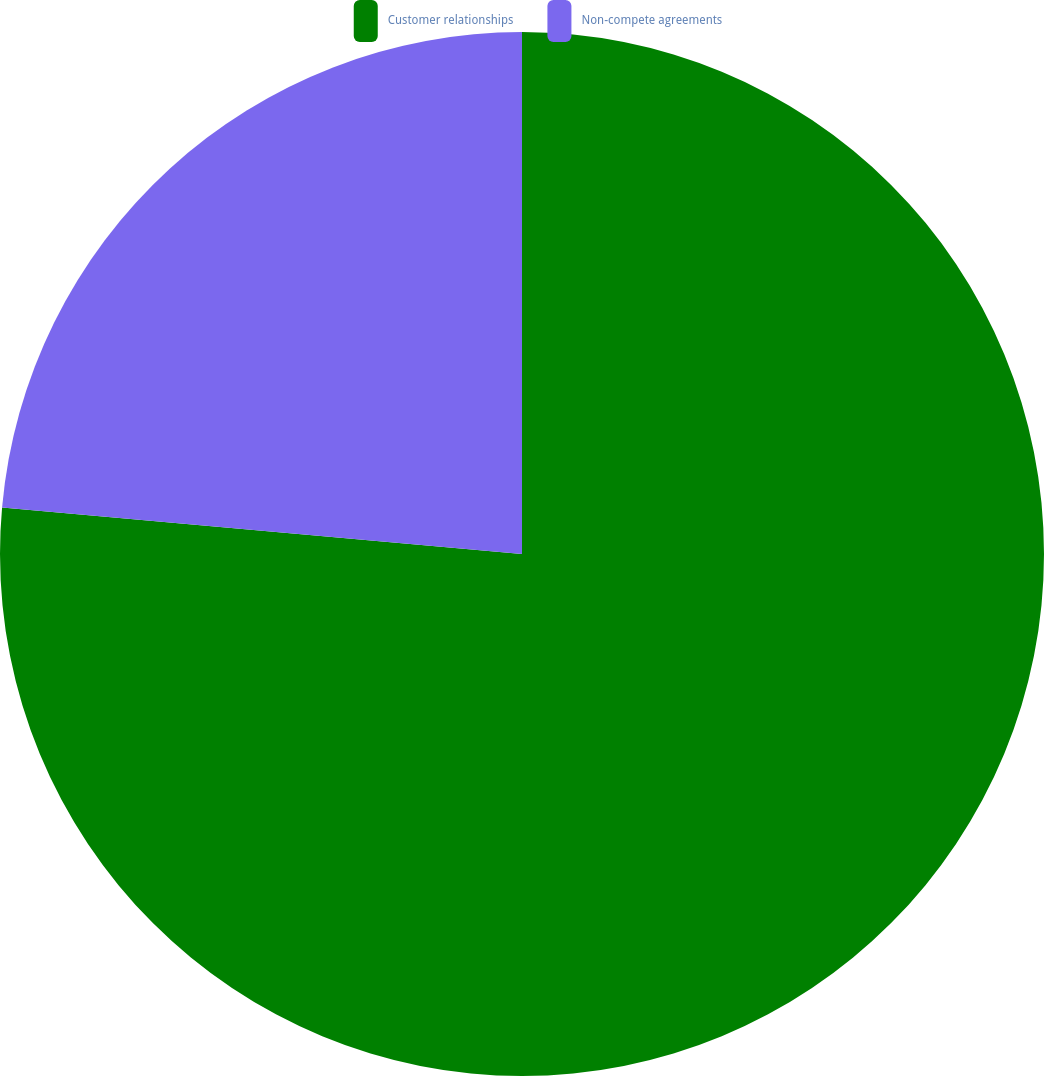Convert chart. <chart><loc_0><loc_0><loc_500><loc_500><pie_chart><fcel>Customer relationships<fcel>Non-compete agreements<nl><fcel>76.42%<fcel>23.58%<nl></chart> 